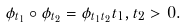<formula> <loc_0><loc_0><loc_500><loc_500>\phi _ { t _ { 1 } } \circ \phi _ { t _ { 2 } } = \phi _ { t _ { 1 } t _ { 2 } } t _ { 1 } , t _ { 2 } > 0 .</formula> 